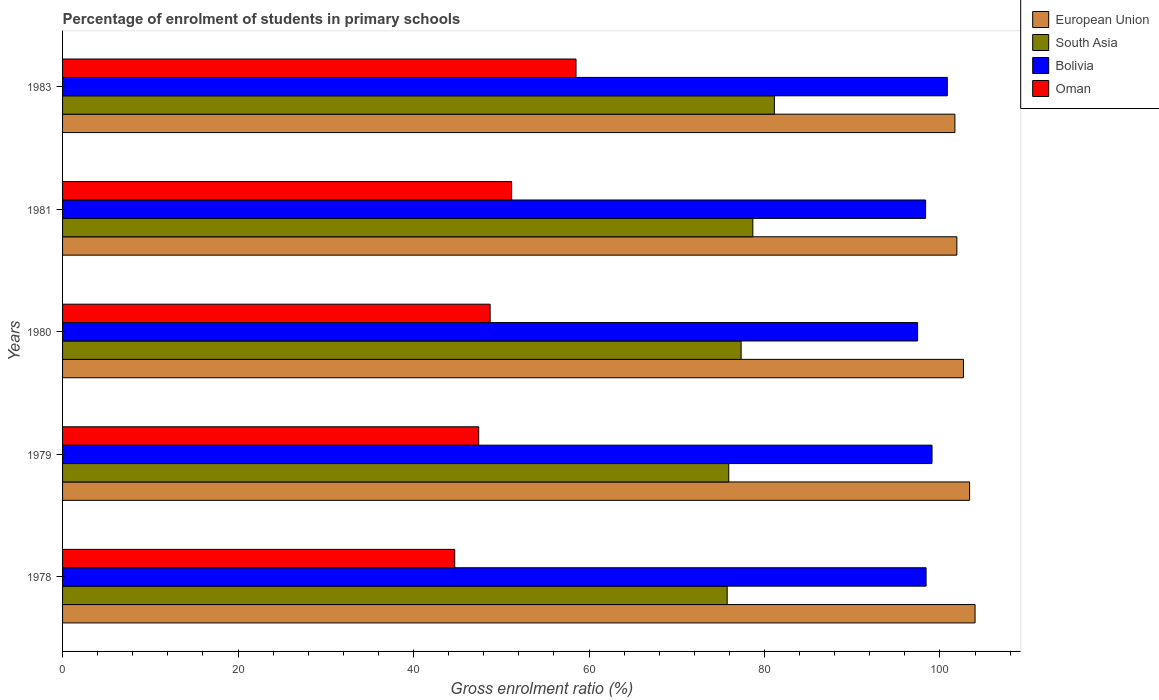How many groups of bars are there?
Ensure brevity in your answer.  5. Are the number of bars on each tick of the Y-axis equal?
Provide a succinct answer. Yes. What is the percentage of students enrolled in primary schools in Oman in 1983?
Keep it short and to the point. 58.52. Across all years, what is the maximum percentage of students enrolled in primary schools in European Union?
Your response must be concise. 104. Across all years, what is the minimum percentage of students enrolled in primary schools in Oman?
Offer a very short reply. 44.7. In which year was the percentage of students enrolled in primary schools in South Asia maximum?
Give a very brief answer. 1983. In which year was the percentage of students enrolled in primary schools in South Asia minimum?
Your answer should be compact. 1978. What is the total percentage of students enrolled in primary schools in South Asia in the graph?
Offer a terse response. 388.82. What is the difference between the percentage of students enrolled in primary schools in European Union in 1981 and that in 1983?
Your answer should be very brief. 0.22. What is the difference between the percentage of students enrolled in primary schools in South Asia in 1979 and the percentage of students enrolled in primary schools in Oman in 1980?
Ensure brevity in your answer.  27.2. What is the average percentage of students enrolled in primary schools in Bolivia per year?
Make the answer very short. 98.83. In the year 1979, what is the difference between the percentage of students enrolled in primary schools in European Union and percentage of students enrolled in primary schools in South Asia?
Offer a very short reply. 27.45. In how many years, is the percentage of students enrolled in primary schools in Oman greater than 88 %?
Give a very brief answer. 0. What is the ratio of the percentage of students enrolled in primary schools in European Union in 1980 to that in 1981?
Your answer should be very brief. 1.01. Is the difference between the percentage of students enrolled in primary schools in European Union in 1981 and 1983 greater than the difference between the percentage of students enrolled in primary schools in South Asia in 1981 and 1983?
Your answer should be compact. Yes. What is the difference between the highest and the second highest percentage of students enrolled in primary schools in Bolivia?
Ensure brevity in your answer.  1.74. What is the difference between the highest and the lowest percentage of students enrolled in primary schools in Bolivia?
Your answer should be very brief. 3.38. In how many years, is the percentage of students enrolled in primary schools in Bolivia greater than the average percentage of students enrolled in primary schools in Bolivia taken over all years?
Offer a terse response. 2. Is the sum of the percentage of students enrolled in primary schools in Oman in 1978 and 1981 greater than the maximum percentage of students enrolled in primary schools in South Asia across all years?
Keep it short and to the point. Yes. Is it the case that in every year, the sum of the percentage of students enrolled in primary schools in Bolivia and percentage of students enrolled in primary schools in European Union is greater than the sum of percentage of students enrolled in primary schools in South Asia and percentage of students enrolled in primary schools in Oman?
Provide a succinct answer. Yes. Are all the bars in the graph horizontal?
Your response must be concise. Yes. What is the difference between two consecutive major ticks on the X-axis?
Ensure brevity in your answer.  20. Are the values on the major ticks of X-axis written in scientific E-notation?
Provide a succinct answer. No. Does the graph contain grids?
Make the answer very short. No. How many legend labels are there?
Provide a succinct answer. 4. What is the title of the graph?
Keep it short and to the point. Percentage of enrolment of students in primary schools. What is the label or title of the X-axis?
Make the answer very short. Gross enrolment ratio (%). What is the Gross enrolment ratio (%) in European Union in 1978?
Keep it short and to the point. 104. What is the Gross enrolment ratio (%) of South Asia in 1978?
Provide a short and direct response. 75.75. What is the Gross enrolment ratio (%) of Bolivia in 1978?
Your answer should be compact. 98.42. What is the Gross enrolment ratio (%) in Oman in 1978?
Offer a very short reply. 44.7. What is the Gross enrolment ratio (%) in European Union in 1979?
Keep it short and to the point. 103.38. What is the Gross enrolment ratio (%) in South Asia in 1979?
Provide a succinct answer. 75.93. What is the Gross enrolment ratio (%) of Bolivia in 1979?
Your response must be concise. 99.1. What is the Gross enrolment ratio (%) of Oman in 1979?
Make the answer very short. 47.43. What is the Gross enrolment ratio (%) in European Union in 1980?
Make the answer very short. 102.68. What is the Gross enrolment ratio (%) in South Asia in 1980?
Ensure brevity in your answer.  77.34. What is the Gross enrolment ratio (%) of Bolivia in 1980?
Offer a very short reply. 97.45. What is the Gross enrolment ratio (%) in Oman in 1980?
Provide a short and direct response. 48.73. What is the Gross enrolment ratio (%) of European Union in 1981?
Give a very brief answer. 101.93. What is the Gross enrolment ratio (%) in South Asia in 1981?
Keep it short and to the point. 78.68. What is the Gross enrolment ratio (%) in Bolivia in 1981?
Your response must be concise. 98.37. What is the Gross enrolment ratio (%) in Oman in 1981?
Offer a very short reply. 51.18. What is the Gross enrolment ratio (%) of European Union in 1983?
Give a very brief answer. 101.7. What is the Gross enrolment ratio (%) in South Asia in 1983?
Offer a terse response. 81.13. What is the Gross enrolment ratio (%) of Bolivia in 1983?
Provide a short and direct response. 100.84. What is the Gross enrolment ratio (%) in Oman in 1983?
Your response must be concise. 58.52. Across all years, what is the maximum Gross enrolment ratio (%) in European Union?
Provide a succinct answer. 104. Across all years, what is the maximum Gross enrolment ratio (%) in South Asia?
Ensure brevity in your answer.  81.13. Across all years, what is the maximum Gross enrolment ratio (%) of Bolivia?
Ensure brevity in your answer.  100.84. Across all years, what is the maximum Gross enrolment ratio (%) in Oman?
Provide a short and direct response. 58.52. Across all years, what is the minimum Gross enrolment ratio (%) in European Union?
Your response must be concise. 101.7. Across all years, what is the minimum Gross enrolment ratio (%) in South Asia?
Ensure brevity in your answer.  75.75. Across all years, what is the minimum Gross enrolment ratio (%) in Bolivia?
Make the answer very short. 97.45. Across all years, what is the minimum Gross enrolment ratio (%) in Oman?
Ensure brevity in your answer.  44.7. What is the total Gross enrolment ratio (%) of European Union in the graph?
Offer a very short reply. 513.69. What is the total Gross enrolment ratio (%) in South Asia in the graph?
Give a very brief answer. 388.82. What is the total Gross enrolment ratio (%) in Bolivia in the graph?
Provide a short and direct response. 494.17. What is the total Gross enrolment ratio (%) of Oman in the graph?
Your response must be concise. 250.56. What is the difference between the Gross enrolment ratio (%) of European Union in 1978 and that in 1979?
Make the answer very short. 0.62. What is the difference between the Gross enrolment ratio (%) in South Asia in 1978 and that in 1979?
Your response must be concise. -0.18. What is the difference between the Gross enrolment ratio (%) of Bolivia in 1978 and that in 1979?
Keep it short and to the point. -0.68. What is the difference between the Gross enrolment ratio (%) in Oman in 1978 and that in 1979?
Your answer should be compact. -2.73. What is the difference between the Gross enrolment ratio (%) of European Union in 1978 and that in 1980?
Your answer should be very brief. 1.32. What is the difference between the Gross enrolment ratio (%) of South Asia in 1978 and that in 1980?
Your response must be concise. -1.59. What is the difference between the Gross enrolment ratio (%) in Bolivia in 1978 and that in 1980?
Offer a terse response. 0.97. What is the difference between the Gross enrolment ratio (%) of Oman in 1978 and that in 1980?
Offer a terse response. -4.03. What is the difference between the Gross enrolment ratio (%) of European Union in 1978 and that in 1981?
Offer a terse response. 2.07. What is the difference between the Gross enrolment ratio (%) in South Asia in 1978 and that in 1981?
Give a very brief answer. -2.93. What is the difference between the Gross enrolment ratio (%) of Bolivia in 1978 and that in 1981?
Offer a terse response. 0.05. What is the difference between the Gross enrolment ratio (%) of Oman in 1978 and that in 1981?
Provide a succinct answer. -6.49. What is the difference between the Gross enrolment ratio (%) of European Union in 1978 and that in 1983?
Your answer should be very brief. 2.3. What is the difference between the Gross enrolment ratio (%) in South Asia in 1978 and that in 1983?
Give a very brief answer. -5.38. What is the difference between the Gross enrolment ratio (%) of Bolivia in 1978 and that in 1983?
Provide a short and direct response. -2.42. What is the difference between the Gross enrolment ratio (%) in Oman in 1978 and that in 1983?
Make the answer very short. -13.82. What is the difference between the Gross enrolment ratio (%) in European Union in 1979 and that in 1980?
Make the answer very short. 0.7. What is the difference between the Gross enrolment ratio (%) in South Asia in 1979 and that in 1980?
Give a very brief answer. -1.41. What is the difference between the Gross enrolment ratio (%) in Bolivia in 1979 and that in 1980?
Your response must be concise. 1.64. What is the difference between the Gross enrolment ratio (%) of Oman in 1979 and that in 1980?
Your answer should be compact. -1.3. What is the difference between the Gross enrolment ratio (%) of European Union in 1979 and that in 1981?
Ensure brevity in your answer.  1.45. What is the difference between the Gross enrolment ratio (%) of South Asia in 1979 and that in 1981?
Provide a succinct answer. -2.75. What is the difference between the Gross enrolment ratio (%) in Bolivia in 1979 and that in 1981?
Offer a very short reply. 0.73. What is the difference between the Gross enrolment ratio (%) of Oman in 1979 and that in 1981?
Offer a terse response. -3.75. What is the difference between the Gross enrolment ratio (%) of European Union in 1979 and that in 1983?
Offer a very short reply. 1.67. What is the difference between the Gross enrolment ratio (%) in South Asia in 1979 and that in 1983?
Ensure brevity in your answer.  -5.2. What is the difference between the Gross enrolment ratio (%) in Bolivia in 1979 and that in 1983?
Ensure brevity in your answer.  -1.74. What is the difference between the Gross enrolment ratio (%) in Oman in 1979 and that in 1983?
Your answer should be compact. -11.09. What is the difference between the Gross enrolment ratio (%) of European Union in 1980 and that in 1981?
Ensure brevity in your answer.  0.75. What is the difference between the Gross enrolment ratio (%) in South Asia in 1980 and that in 1981?
Your response must be concise. -1.34. What is the difference between the Gross enrolment ratio (%) in Bolivia in 1980 and that in 1981?
Your response must be concise. -0.91. What is the difference between the Gross enrolment ratio (%) in Oman in 1980 and that in 1981?
Give a very brief answer. -2.45. What is the difference between the Gross enrolment ratio (%) of European Union in 1980 and that in 1983?
Offer a very short reply. 0.97. What is the difference between the Gross enrolment ratio (%) of South Asia in 1980 and that in 1983?
Your answer should be compact. -3.79. What is the difference between the Gross enrolment ratio (%) of Bolivia in 1980 and that in 1983?
Keep it short and to the point. -3.38. What is the difference between the Gross enrolment ratio (%) of Oman in 1980 and that in 1983?
Provide a succinct answer. -9.79. What is the difference between the Gross enrolment ratio (%) in European Union in 1981 and that in 1983?
Provide a succinct answer. 0.22. What is the difference between the Gross enrolment ratio (%) in South Asia in 1981 and that in 1983?
Keep it short and to the point. -2.45. What is the difference between the Gross enrolment ratio (%) of Bolivia in 1981 and that in 1983?
Your answer should be very brief. -2.47. What is the difference between the Gross enrolment ratio (%) in Oman in 1981 and that in 1983?
Provide a succinct answer. -7.34. What is the difference between the Gross enrolment ratio (%) of European Union in 1978 and the Gross enrolment ratio (%) of South Asia in 1979?
Offer a very short reply. 28.07. What is the difference between the Gross enrolment ratio (%) of European Union in 1978 and the Gross enrolment ratio (%) of Bolivia in 1979?
Ensure brevity in your answer.  4.9. What is the difference between the Gross enrolment ratio (%) of European Union in 1978 and the Gross enrolment ratio (%) of Oman in 1979?
Your response must be concise. 56.57. What is the difference between the Gross enrolment ratio (%) in South Asia in 1978 and the Gross enrolment ratio (%) in Bolivia in 1979?
Offer a terse response. -23.35. What is the difference between the Gross enrolment ratio (%) of South Asia in 1978 and the Gross enrolment ratio (%) of Oman in 1979?
Ensure brevity in your answer.  28.32. What is the difference between the Gross enrolment ratio (%) in Bolivia in 1978 and the Gross enrolment ratio (%) in Oman in 1979?
Your answer should be very brief. 50.99. What is the difference between the Gross enrolment ratio (%) in European Union in 1978 and the Gross enrolment ratio (%) in South Asia in 1980?
Give a very brief answer. 26.66. What is the difference between the Gross enrolment ratio (%) in European Union in 1978 and the Gross enrolment ratio (%) in Bolivia in 1980?
Offer a terse response. 6.55. What is the difference between the Gross enrolment ratio (%) in European Union in 1978 and the Gross enrolment ratio (%) in Oman in 1980?
Give a very brief answer. 55.27. What is the difference between the Gross enrolment ratio (%) in South Asia in 1978 and the Gross enrolment ratio (%) in Bolivia in 1980?
Offer a very short reply. -21.7. What is the difference between the Gross enrolment ratio (%) of South Asia in 1978 and the Gross enrolment ratio (%) of Oman in 1980?
Your answer should be very brief. 27.02. What is the difference between the Gross enrolment ratio (%) of Bolivia in 1978 and the Gross enrolment ratio (%) of Oman in 1980?
Ensure brevity in your answer.  49.69. What is the difference between the Gross enrolment ratio (%) in European Union in 1978 and the Gross enrolment ratio (%) in South Asia in 1981?
Provide a succinct answer. 25.32. What is the difference between the Gross enrolment ratio (%) in European Union in 1978 and the Gross enrolment ratio (%) in Bolivia in 1981?
Offer a very short reply. 5.64. What is the difference between the Gross enrolment ratio (%) of European Union in 1978 and the Gross enrolment ratio (%) of Oman in 1981?
Provide a short and direct response. 52.82. What is the difference between the Gross enrolment ratio (%) of South Asia in 1978 and the Gross enrolment ratio (%) of Bolivia in 1981?
Offer a very short reply. -22.62. What is the difference between the Gross enrolment ratio (%) of South Asia in 1978 and the Gross enrolment ratio (%) of Oman in 1981?
Provide a short and direct response. 24.57. What is the difference between the Gross enrolment ratio (%) in Bolivia in 1978 and the Gross enrolment ratio (%) in Oman in 1981?
Offer a terse response. 47.24. What is the difference between the Gross enrolment ratio (%) of European Union in 1978 and the Gross enrolment ratio (%) of South Asia in 1983?
Offer a very short reply. 22.87. What is the difference between the Gross enrolment ratio (%) in European Union in 1978 and the Gross enrolment ratio (%) in Bolivia in 1983?
Offer a terse response. 3.16. What is the difference between the Gross enrolment ratio (%) of European Union in 1978 and the Gross enrolment ratio (%) of Oman in 1983?
Make the answer very short. 45.48. What is the difference between the Gross enrolment ratio (%) in South Asia in 1978 and the Gross enrolment ratio (%) in Bolivia in 1983?
Provide a short and direct response. -25.09. What is the difference between the Gross enrolment ratio (%) in South Asia in 1978 and the Gross enrolment ratio (%) in Oman in 1983?
Offer a terse response. 17.23. What is the difference between the Gross enrolment ratio (%) in Bolivia in 1978 and the Gross enrolment ratio (%) in Oman in 1983?
Your response must be concise. 39.9. What is the difference between the Gross enrolment ratio (%) of European Union in 1979 and the Gross enrolment ratio (%) of South Asia in 1980?
Provide a short and direct response. 26.04. What is the difference between the Gross enrolment ratio (%) of European Union in 1979 and the Gross enrolment ratio (%) of Bolivia in 1980?
Make the answer very short. 5.93. What is the difference between the Gross enrolment ratio (%) of European Union in 1979 and the Gross enrolment ratio (%) of Oman in 1980?
Your answer should be very brief. 54.65. What is the difference between the Gross enrolment ratio (%) in South Asia in 1979 and the Gross enrolment ratio (%) in Bolivia in 1980?
Make the answer very short. -21.52. What is the difference between the Gross enrolment ratio (%) of South Asia in 1979 and the Gross enrolment ratio (%) of Oman in 1980?
Keep it short and to the point. 27.2. What is the difference between the Gross enrolment ratio (%) in Bolivia in 1979 and the Gross enrolment ratio (%) in Oman in 1980?
Provide a short and direct response. 50.36. What is the difference between the Gross enrolment ratio (%) in European Union in 1979 and the Gross enrolment ratio (%) in South Asia in 1981?
Provide a succinct answer. 24.7. What is the difference between the Gross enrolment ratio (%) in European Union in 1979 and the Gross enrolment ratio (%) in Bolivia in 1981?
Your answer should be very brief. 5.01. What is the difference between the Gross enrolment ratio (%) in European Union in 1979 and the Gross enrolment ratio (%) in Oman in 1981?
Your answer should be very brief. 52.2. What is the difference between the Gross enrolment ratio (%) of South Asia in 1979 and the Gross enrolment ratio (%) of Bolivia in 1981?
Your answer should be compact. -22.44. What is the difference between the Gross enrolment ratio (%) in South Asia in 1979 and the Gross enrolment ratio (%) in Oman in 1981?
Provide a succinct answer. 24.75. What is the difference between the Gross enrolment ratio (%) of Bolivia in 1979 and the Gross enrolment ratio (%) of Oman in 1981?
Your answer should be very brief. 47.91. What is the difference between the Gross enrolment ratio (%) of European Union in 1979 and the Gross enrolment ratio (%) of South Asia in 1983?
Keep it short and to the point. 22.25. What is the difference between the Gross enrolment ratio (%) in European Union in 1979 and the Gross enrolment ratio (%) in Bolivia in 1983?
Make the answer very short. 2.54. What is the difference between the Gross enrolment ratio (%) in European Union in 1979 and the Gross enrolment ratio (%) in Oman in 1983?
Your answer should be very brief. 44.86. What is the difference between the Gross enrolment ratio (%) of South Asia in 1979 and the Gross enrolment ratio (%) of Bolivia in 1983?
Provide a short and direct response. -24.91. What is the difference between the Gross enrolment ratio (%) in South Asia in 1979 and the Gross enrolment ratio (%) in Oman in 1983?
Provide a succinct answer. 17.41. What is the difference between the Gross enrolment ratio (%) in Bolivia in 1979 and the Gross enrolment ratio (%) in Oman in 1983?
Give a very brief answer. 40.58. What is the difference between the Gross enrolment ratio (%) of European Union in 1980 and the Gross enrolment ratio (%) of Bolivia in 1981?
Keep it short and to the point. 4.31. What is the difference between the Gross enrolment ratio (%) of European Union in 1980 and the Gross enrolment ratio (%) of Oman in 1981?
Provide a short and direct response. 51.49. What is the difference between the Gross enrolment ratio (%) of South Asia in 1980 and the Gross enrolment ratio (%) of Bolivia in 1981?
Your answer should be very brief. -21.03. What is the difference between the Gross enrolment ratio (%) of South Asia in 1980 and the Gross enrolment ratio (%) of Oman in 1981?
Ensure brevity in your answer.  26.16. What is the difference between the Gross enrolment ratio (%) of Bolivia in 1980 and the Gross enrolment ratio (%) of Oman in 1981?
Provide a succinct answer. 46.27. What is the difference between the Gross enrolment ratio (%) of European Union in 1980 and the Gross enrolment ratio (%) of South Asia in 1983?
Ensure brevity in your answer.  21.55. What is the difference between the Gross enrolment ratio (%) of European Union in 1980 and the Gross enrolment ratio (%) of Bolivia in 1983?
Your answer should be compact. 1.84. What is the difference between the Gross enrolment ratio (%) of European Union in 1980 and the Gross enrolment ratio (%) of Oman in 1983?
Your answer should be compact. 44.15. What is the difference between the Gross enrolment ratio (%) in South Asia in 1980 and the Gross enrolment ratio (%) in Bolivia in 1983?
Your answer should be very brief. -23.5. What is the difference between the Gross enrolment ratio (%) in South Asia in 1980 and the Gross enrolment ratio (%) in Oman in 1983?
Keep it short and to the point. 18.82. What is the difference between the Gross enrolment ratio (%) in Bolivia in 1980 and the Gross enrolment ratio (%) in Oman in 1983?
Keep it short and to the point. 38.93. What is the difference between the Gross enrolment ratio (%) in European Union in 1981 and the Gross enrolment ratio (%) in South Asia in 1983?
Offer a terse response. 20.8. What is the difference between the Gross enrolment ratio (%) in European Union in 1981 and the Gross enrolment ratio (%) in Bolivia in 1983?
Provide a succinct answer. 1.09. What is the difference between the Gross enrolment ratio (%) of European Union in 1981 and the Gross enrolment ratio (%) of Oman in 1983?
Offer a terse response. 43.41. What is the difference between the Gross enrolment ratio (%) of South Asia in 1981 and the Gross enrolment ratio (%) of Bolivia in 1983?
Give a very brief answer. -22.16. What is the difference between the Gross enrolment ratio (%) in South Asia in 1981 and the Gross enrolment ratio (%) in Oman in 1983?
Make the answer very short. 20.15. What is the difference between the Gross enrolment ratio (%) of Bolivia in 1981 and the Gross enrolment ratio (%) of Oman in 1983?
Keep it short and to the point. 39.84. What is the average Gross enrolment ratio (%) of European Union per year?
Your response must be concise. 102.74. What is the average Gross enrolment ratio (%) in South Asia per year?
Offer a very short reply. 77.76. What is the average Gross enrolment ratio (%) of Bolivia per year?
Your response must be concise. 98.83. What is the average Gross enrolment ratio (%) in Oman per year?
Make the answer very short. 50.11. In the year 1978, what is the difference between the Gross enrolment ratio (%) in European Union and Gross enrolment ratio (%) in South Asia?
Ensure brevity in your answer.  28.25. In the year 1978, what is the difference between the Gross enrolment ratio (%) in European Union and Gross enrolment ratio (%) in Bolivia?
Ensure brevity in your answer.  5.58. In the year 1978, what is the difference between the Gross enrolment ratio (%) of European Union and Gross enrolment ratio (%) of Oman?
Provide a short and direct response. 59.3. In the year 1978, what is the difference between the Gross enrolment ratio (%) in South Asia and Gross enrolment ratio (%) in Bolivia?
Your answer should be compact. -22.67. In the year 1978, what is the difference between the Gross enrolment ratio (%) of South Asia and Gross enrolment ratio (%) of Oman?
Provide a succinct answer. 31.05. In the year 1978, what is the difference between the Gross enrolment ratio (%) in Bolivia and Gross enrolment ratio (%) in Oman?
Your response must be concise. 53.72. In the year 1979, what is the difference between the Gross enrolment ratio (%) of European Union and Gross enrolment ratio (%) of South Asia?
Give a very brief answer. 27.45. In the year 1979, what is the difference between the Gross enrolment ratio (%) in European Union and Gross enrolment ratio (%) in Bolivia?
Your response must be concise. 4.28. In the year 1979, what is the difference between the Gross enrolment ratio (%) of European Union and Gross enrolment ratio (%) of Oman?
Make the answer very short. 55.95. In the year 1979, what is the difference between the Gross enrolment ratio (%) of South Asia and Gross enrolment ratio (%) of Bolivia?
Give a very brief answer. -23.17. In the year 1979, what is the difference between the Gross enrolment ratio (%) in South Asia and Gross enrolment ratio (%) in Oman?
Your answer should be very brief. 28.5. In the year 1979, what is the difference between the Gross enrolment ratio (%) in Bolivia and Gross enrolment ratio (%) in Oman?
Provide a succinct answer. 51.67. In the year 1980, what is the difference between the Gross enrolment ratio (%) of European Union and Gross enrolment ratio (%) of South Asia?
Provide a succinct answer. 25.34. In the year 1980, what is the difference between the Gross enrolment ratio (%) in European Union and Gross enrolment ratio (%) in Bolivia?
Your answer should be compact. 5.22. In the year 1980, what is the difference between the Gross enrolment ratio (%) of European Union and Gross enrolment ratio (%) of Oman?
Your answer should be compact. 53.94. In the year 1980, what is the difference between the Gross enrolment ratio (%) in South Asia and Gross enrolment ratio (%) in Bolivia?
Keep it short and to the point. -20.12. In the year 1980, what is the difference between the Gross enrolment ratio (%) in South Asia and Gross enrolment ratio (%) in Oman?
Ensure brevity in your answer.  28.61. In the year 1980, what is the difference between the Gross enrolment ratio (%) in Bolivia and Gross enrolment ratio (%) in Oman?
Your response must be concise. 48.72. In the year 1981, what is the difference between the Gross enrolment ratio (%) in European Union and Gross enrolment ratio (%) in South Asia?
Your response must be concise. 23.25. In the year 1981, what is the difference between the Gross enrolment ratio (%) of European Union and Gross enrolment ratio (%) of Bolivia?
Offer a terse response. 3.56. In the year 1981, what is the difference between the Gross enrolment ratio (%) in European Union and Gross enrolment ratio (%) in Oman?
Make the answer very short. 50.74. In the year 1981, what is the difference between the Gross enrolment ratio (%) in South Asia and Gross enrolment ratio (%) in Bolivia?
Ensure brevity in your answer.  -19.69. In the year 1981, what is the difference between the Gross enrolment ratio (%) of South Asia and Gross enrolment ratio (%) of Oman?
Offer a very short reply. 27.49. In the year 1981, what is the difference between the Gross enrolment ratio (%) of Bolivia and Gross enrolment ratio (%) of Oman?
Your answer should be very brief. 47.18. In the year 1983, what is the difference between the Gross enrolment ratio (%) in European Union and Gross enrolment ratio (%) in South Asia?
Provide a succinct answer. 20.58. In the year 1983, what is the difference between the Gross enrolment ratio (%) in European Union and Gross enrolment ratio (%) in Bolivia?
Offer a terse response. 0.87. In the year 1983, what is the difference between the Gross enrolment ratio (%) of European Union and Gross enrolment ratio (%) of Oman?
Keep it short and to the point. 43.18. In the year 1983, what is the difference between the Gross enrolment ratio (%) in South Asia and Gross enrolment ratio (%) in Bolivia?
Offer a terse response. -19.71. In the year 1983, what is the difference between the Gross enrolment ratio (%) of South Asia and Gross enrolment ratio (%) of Oman?
Offer a terse response. 22.61. In the year 1983, what is the difference between the Gross enrolment ratio (%) in Bolivia and Gross enrolment ratio (%) in Oman?
Ensure brevity in your answer.  42.32. What is the ratio of the Gross enrolment ratio (%) in Oman in 1978 to that in 1979?
Your answer should be compact. 0.94. What is the ratio of the Gross enrolment ratio (%) in European Union in 1978 to that in 1980?
Offer a very short reply. 1.01. What is the ratio of the Gross enrolment ratio (%) in South Asia in 1978 to that in 1980?
Provide a short and direct response. 0.98. What is the ratio of the Gross enrolment ratio (%) in Bolivia in 1978 to that in 1980?
Your answer should be compact. 1.01. What is the ratio of the Gross enrolment ratio (%) of Oman in 1978 to that in 1980?
Make the answer very short. 0.92. What is the ratio of the Gross enrolment ratio (%) of European Union in 1978 to that in 1981?
Provide a short and direct response. 1.02. What is the ratio of the Gross enrolment ratio (%) in South Asia in 1978 to that in 1981?
Give a very brief answer. 0.96. What is the ratio of the Gross enrolment ratio (%) in Oman in 1978 to that in 1981?
Ensure brevity in your answer.  0.87. What is the ratio of the Gross enrolment ratio (%) of European Union in 1978 to that in 1983?
Ensure brevity in your answer.  1.02. What is the ratio of the Gross enrolment ratio (%) of South Asia in 1978 to that in 1983?
Give a very brief answer. 0.93. What is the ratio of the Gross enrolment ratio (%) in Bolivia in 1978 to that in 1983?
Make the answer very short. 0.98. What is the ratio of the Gross enrolment ratio (%) of Oman in 1978 to that in 1983?
Your answer should be compact. 0.76. What is the ratio of the Gross enrolment ratio (%) in South Asia in 1979 to that in 1980?
Give a very brief answer. 0.98. What is the ratio of the Gross enrolment ratio (%) in Bolivia in 1979 to that in 1980?
Ensure brevity in your answer.  1.02. What is the ratio of the Gross enrolment ratio (%) of Oman in 1979 to that in 1980?
Keep it short and to the point. 0.97. What is the ratio of the Gross enrolment ratio (%) of European Union in 1979 to that in 1981?
Ensure brevity in your answer.  1.01. What is the ratio of the Gross enrolment ratio (%) of South Asia in 1979 to that in 1981?
Keep it short and to the point. 0.97. What is the ratio of the Gross enrolment ratio (%) in Bolivia in 1979 to that in 1981?
Keep it short and to the point. 1.01. What is the ratio of the Gross enrolment ratio (%) of Oman in 1979 to that in 1981?
Offer a terse response. 0.93. What is the ratio of the Gross enrolment ratio (%) in European Union in 1979 to that in 1983?
Ensure brevity in your answer.  1.02. What is the ratio of the Gross enrolment ratio (%) in South Asia in 1979 to that in 1983?
Your answer should be very brief. 0.94. What is the ratio of the Gross enrolment ratio (%) of Bolivia in 1979 to that in 1983?
Your answer should be very brief. 0.98. What is the ratio of the Gross enrolment ratio (%) in Oman in 1979 to that in 1983?
Give a very brief answer. 0.81. What is the ratio of the Gross enrolment ratio (%) in European Union in 1980 to that in 1981?
Your answer should be compact. 1.01. What is the ratio of the Gross enrolment ratio (%) of South Asia in 1980 to that in 1981?
Give a very brief answer. 0.98. What is the ratio of the Gross enrolment ratio (%) of Bolivia in 1980 to that in 1981?
Offer a terse response. 0.99. What is the ratio of the Gross enrolment ratio (%) of Oman in 1980 to that in 1981?
Provide a short and direct response. 0.95. What is the ratio of the Gross enrolment ratio (%) in European Union in 1980 to that in 1983?
Give a very brief answer. 1.01. What is the ratio of the Gross enrolment ratio (%) of South Asia in 1980 to that in 1983?
Provide a short and direct response. 0.95. What is the ratio of the Gross enrolment ratio (%) of Bolivia in 1980 to that in 1983?
Offer a very short reply. 0.97. What is the ratio of the Gross enrolment ratio (%) of Oman in 1980 to that in 1983?
Ensure brevity in your answer.  0.83. What is the ratio of the Gross enrolment ratio (%) in South Asia in 1981 to that in 1983?
Offer a terse response. 0.97. What is the ratio of the Gross enrolment ratio (%) of Bolivia in 1981 to that in 1983?
Your answer should be very brief. 0.98. What is the ratio of the Gross enrolment ratio (%) in Oman in 1981 to that in 1983?
Provide a succinct answer. 0.87. What is the difference between the highest and the second highest Gross enrolment ratio (%) in European Union?
Your answer should be very brief. 0.62. What is the difference between the highest and the second highest Gross enrolment ratio (%) of South Asia?
Offer a very short reply. 2.45. What is the difference between the highest and the second highest Gross enrolment ratio (%) of Bolivia?
Offer a very short reply. 1.74. What is the difference between the highest and the second highest Gross enrolment ratio (%) in Oman?
Make the answer very short. 7.34. What is the difference between the highest and the lowest Gross enrolment ratio (%) in European Union?
Make the answer very short. 2.3. What is the difference between the highest and the lowest Gross enrolment ratio (%) of South Asia?
Your answer should be compact. 5.38. What is the difference between the highest and the lowest Gross enrolment ratio (%) in Bolivia?
Provide a short and direct response. 3.38. What is the difference between the highest and the lowest Gross enrolment ratio (%) of Oman?
Ensure brevity in your answer.  13.82. 